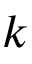<formula> <loc_0><loc_0><loc_500><loc_500>k</formula> 